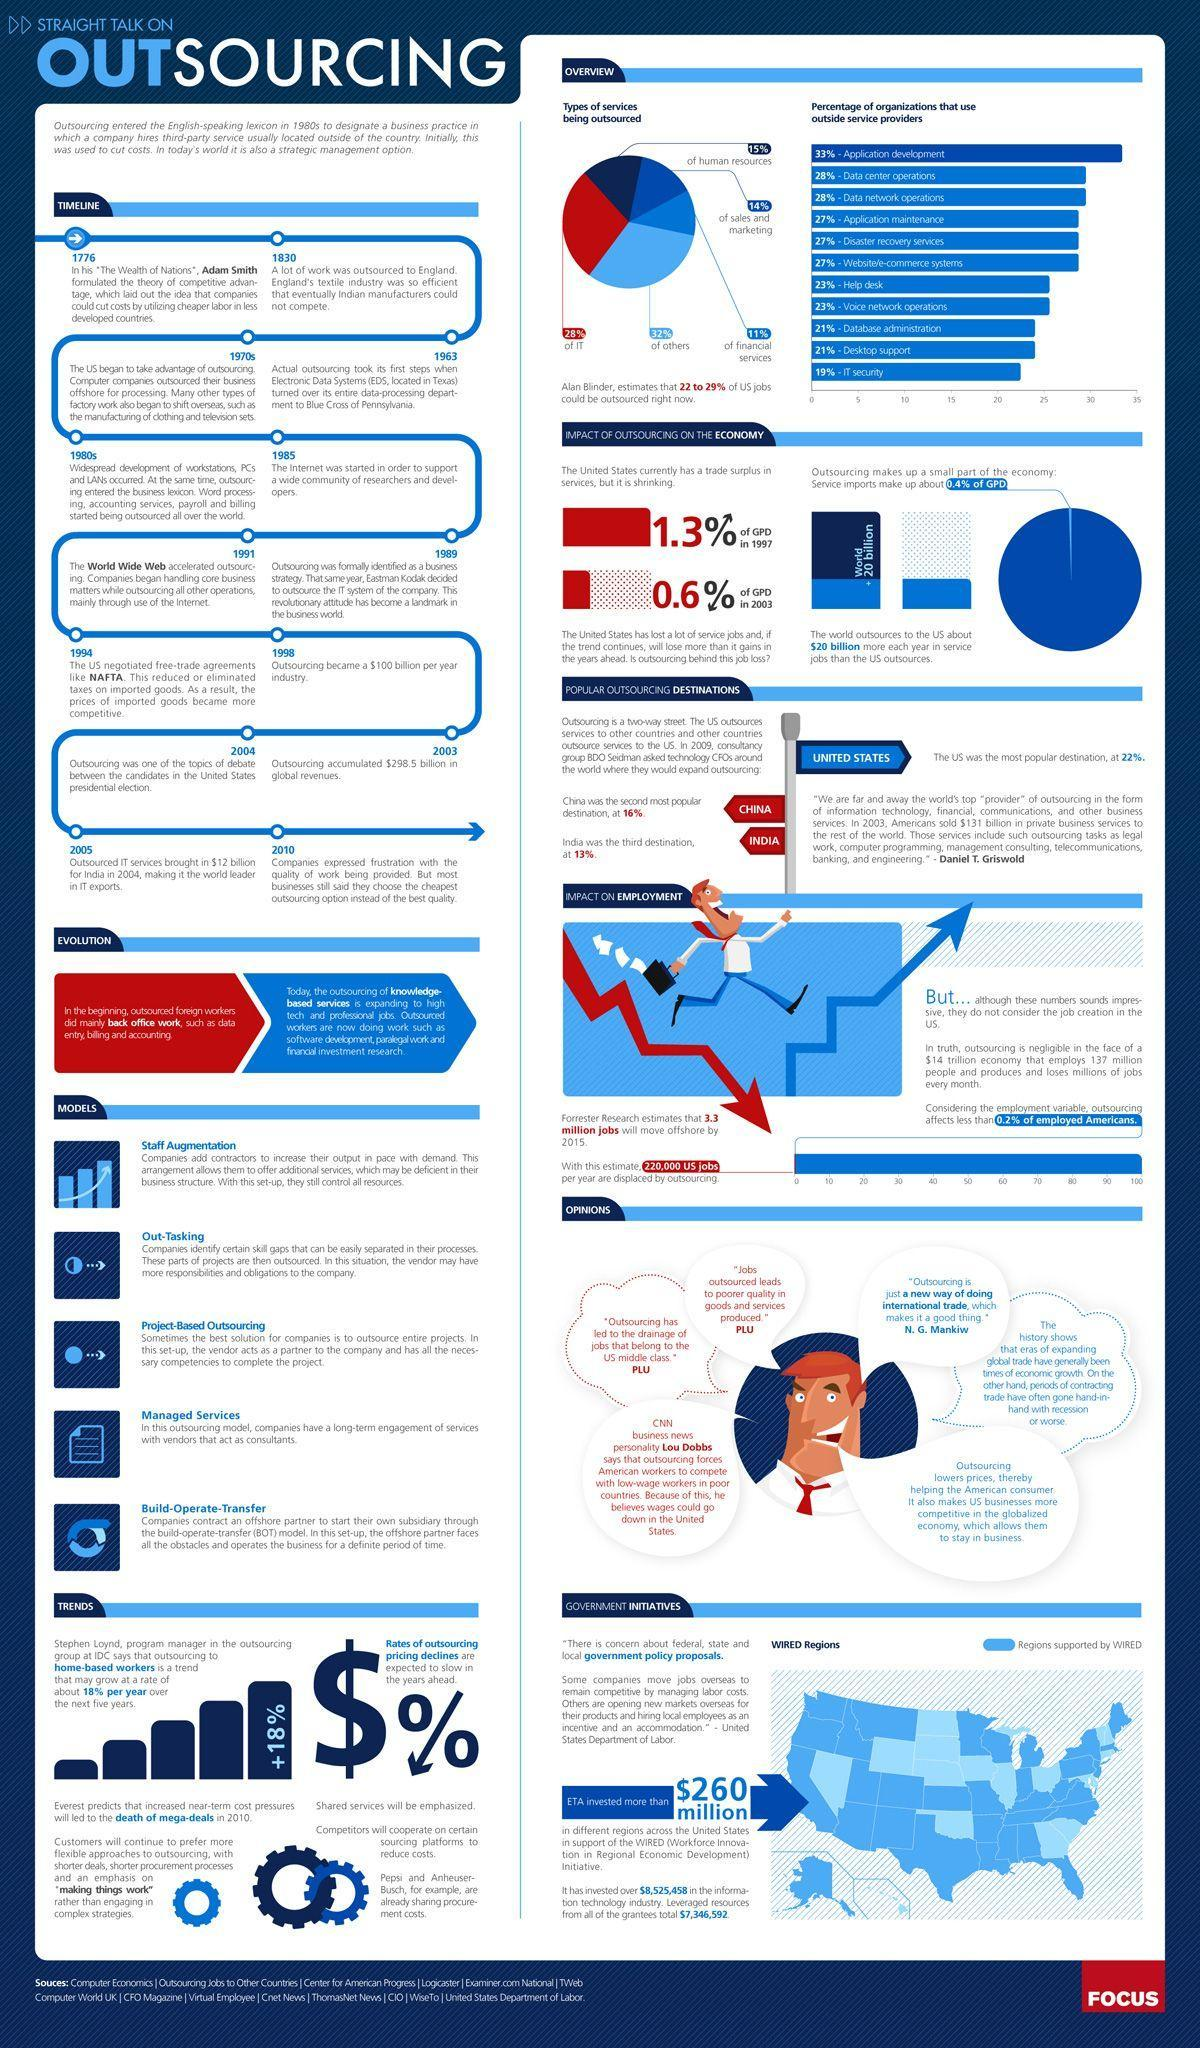How many types of services are being outsourced?
Answer the question with a short phrase. 5 What is the difference in percentage between organizations outsourcing application development and IT security? 14% When was the first outsourcing recorded? 1963 Which year lead way to the genesis of internet, 1991, 1985, or 1776? 1985 Which countries hold the first three ranks in outsourcing? United States, China, India 